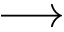Convert formula to latex. <formula><loc_0><loc_0><loc_500><loc_500>\longrightarrow</formula> 